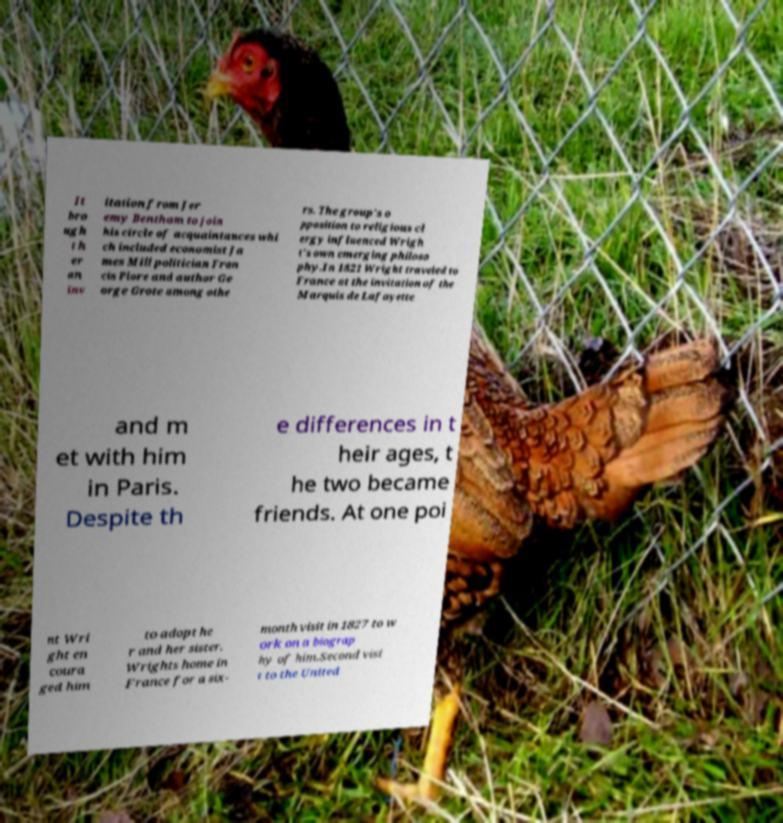Can you read and provide the text displayed in the image?This photo seems to have some interesting text. Can you extract and type it out for me? It bro ugh t h er an inv itation from Jer emy Bentham to join his circle of acquaintances whi ch included economist Ja mes Mill politician Fran cis Plore and author Ge orge Grote among othe rs. The group's o pposition to religious cl ergy influenced Wrigh t's own emerging philoso phy.In 1821 Wright traveled to France at the invitation of the Marquis de Lafayette and m et with him in Paris. Despite th e differences in t heir ages, t he two became friends. At one poi nt Wri ght en coura ged him to adopt he r and her sister. Wrights home in France for a six- month visit in 1827 to w ork on a biograp hy of him.Second visi t to the United 